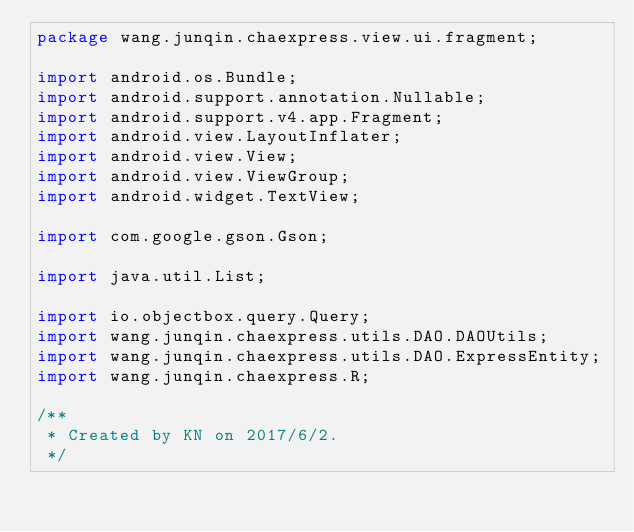Convert code to text. <code><loc_0><loc_0><loc_500><loc_500><_Java_>package wang.junqin.chaexpress.view.ui.fragment;

import android.os.Bundle;
import android.support.annotation.Nullable;
import android.support.v4.app.Fragment;
import android.view.LayoutInflater;
import android.view.View;
import android.view.ViewGroup;
import android.widget.TextView;

import com.google.gson.Gson;

import java.util.List;

import io.objectbox.query.Query;
import wang.junqin.chaexpress.utils.DAO.DAOUtils;
import wang.junqin.chaexpress.utils.DAO.ExpressEntity;
import wang.junqin.chaexpress.R;

/**
 * Created by KN on 2017/6/2.
 */
</code> 